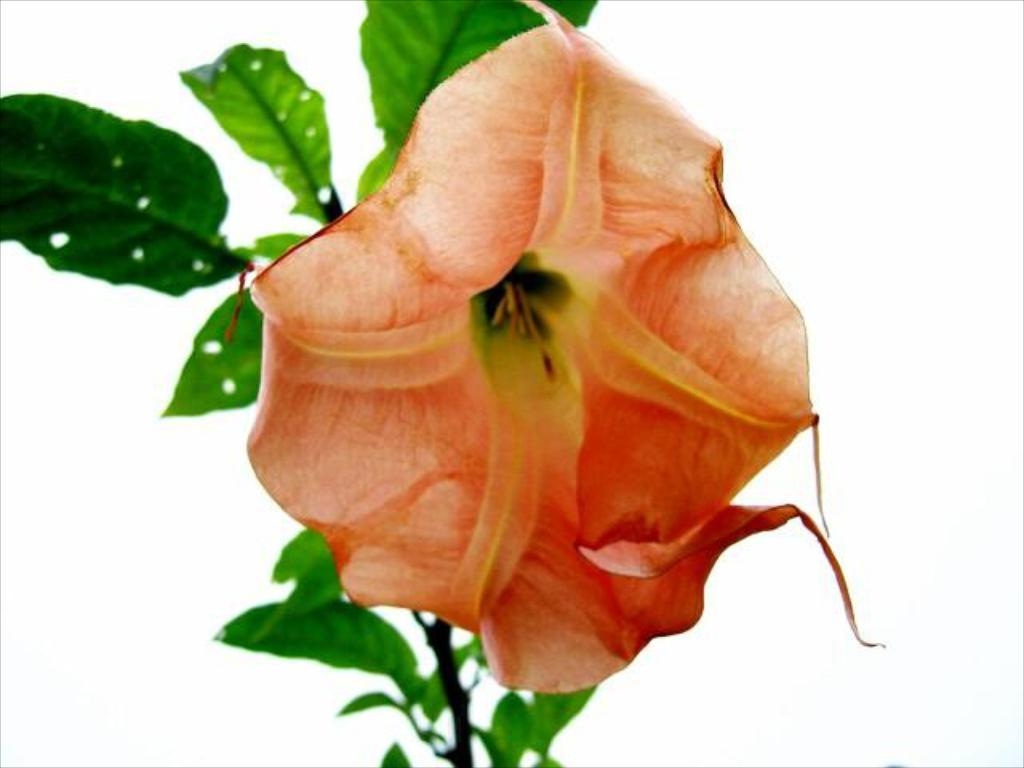What is located in the foreground of the image? There is a flower and leaves in the foreground of the image. What color is the background of the image? The background of the image is white. What grade does the flower receive for its performance in the image? There is no grading system or performance evaluation for the flower in the image. 